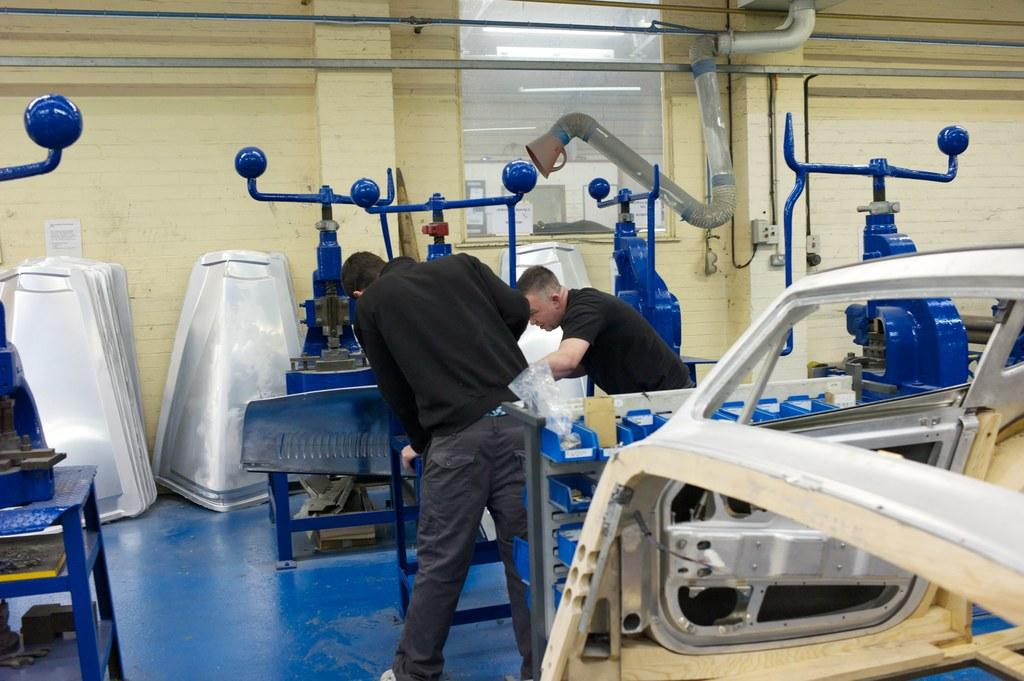What can be observed about the objects in the image? There are groups of objects in the image, and they have a blue color. How many people are present in the image? There are two persons in the image. What are the two persons doing with the objects? The two persons are holding the objects. What type of design can be seen on the rifle in the image? There is no rifle present in the image; the objects are blue and held by the two persons. 